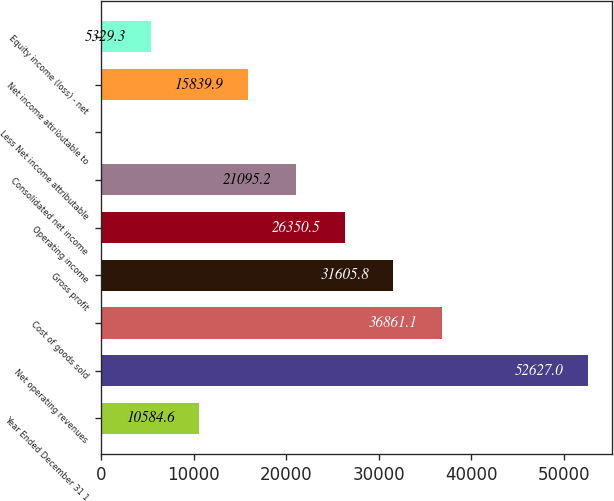Convert chart to OTSL. <chart><loc_0><loc_0><loc_500><loc_500><bar_chart><fcel>Year Ended December 31 1<fcel>Net operating revenues<fcel>Cost of goods sold<fcel>Gross profit<fcel>Operating income<fcel>Consolidated net income<fcel>Less Net income attributable<fcel>Net income attributable to<fcel>Equity income (loss) - net<nl><fcel>10584.6<fcel>52627<fcel>36861.1<fcel>31605.8<fcel>26350.5<fcel>21095.2<fcel>74<fcel>15839.9<fcel>5329.3<nl></chart> 